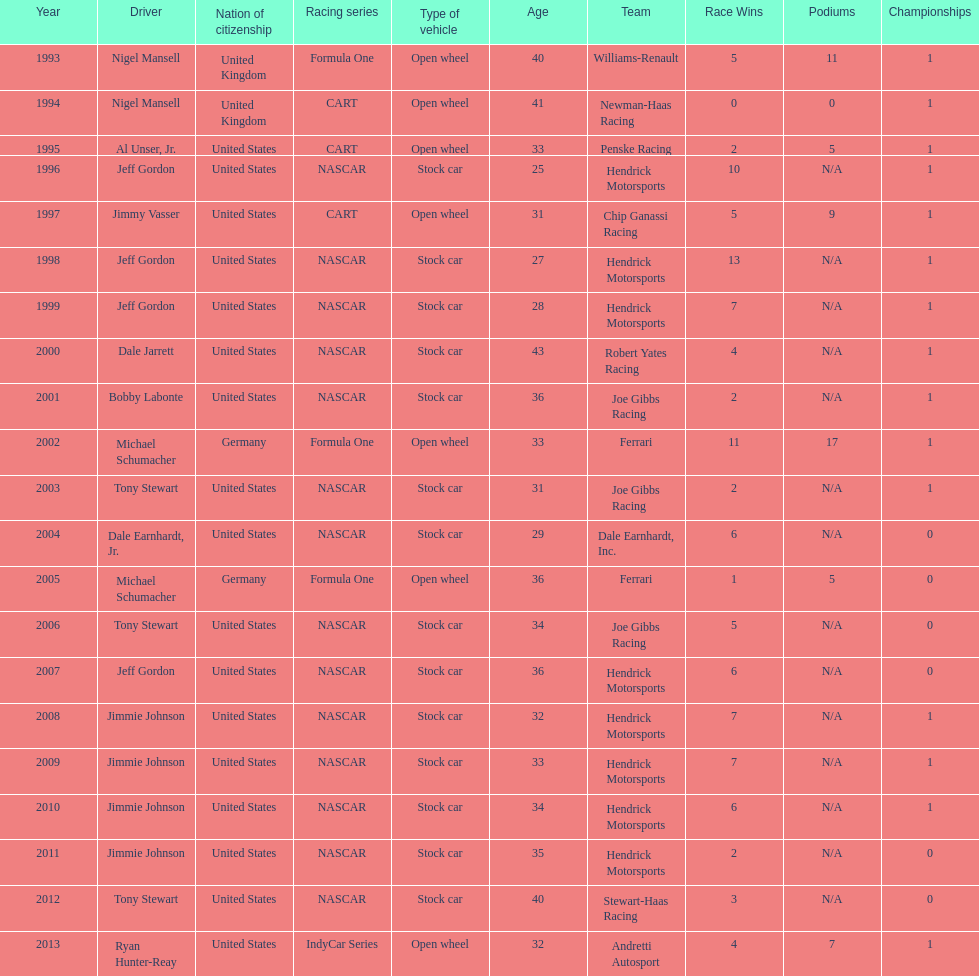Out of these drivers: nigel mansell, al unser, jr., michael schumacher, and jeff gordon, all but one has more than one espy award. who only has one espy award? Al Unser, Jr. Could you parse the entire table? {'header': ['Year', 'Driver', 'Nation of citizenship', 'Racing series', 'Type of vehicle', 'Age', 'Team', 'Race Wins', 'Podiums', 'Championships'], 'rows': [['1993', 'Nigel Mansell', 'United Kingdom', 'Formula One', 'Open wheel', '40', 'Williams-Renault', '5', '11', '1'], ['1994', 'Nigel Mansell', 'United Kingdom', 'CART', 'Open wheel', '41', 'Newman-Haas Racing', '0', '0', '1'], ['1995', 'Al Unser, Jr.', 'United States', 'CART', 'Open wheel', '33', 'Penske Racing', '2', '5', '1'], ['1996', 'Jeff Gordon', 'United States', 'NASCAR', 'Stock car', '25', 'Hendrick Motorsports', '10', 'N/A', '1'], ['1997', 'Jimmy Vasser', 'United States', 'CART', 'Open wheel', '31', 'Chip Ganassi Racing', '5', '9', '1'], ['1998', 'Jeff Gordon', 'United States', 'NASCAR', 'Stock car', '27', 'Hendrick Motorsports', '13', 'N/A', '1'], ['1999', 'Jeff Gordon', 'United States', 'NASCAR', 'Stock car', '28', 'Hendrick Motorsports', '7', 'N/A', '1'], ['2000', 'Dale Jarrett', 'United States', 'NASCAR', 'Stock car', '43', 'Robert Yates Racing', '4', 'N/A', '1'], ['2001', 'Bobby Labonte', 'United States', 'NASCAR', 'Stock car', '36', 'Joe Gibbs Racing', '2', 'N/A', '1'], ['2002', 'Michael Schumacher', 'Germany', 'Formula One', 'Open wheel', '33', 'Ferrari', '11', '17', '1'], ['2003', 'Tony Stewart', 'United States', 'NASCAR', 'Stock car', '31', 'Joe Gibbs Racing', '2', 'N/A', '1'], ['2004', 'Dale Earnhardt, Jr.', 'United States', 'NASCAR', 'Stock car', '29', 'Dale Earnhardt, Inc.', '6', 'N/A', '0'], ['2005', 'Michael Schumacher', 'Germany', 'Formula One', 'Open wheel', '36', 'Ferrari', '1', '5', '0'], ['2006', 'Tony Stewart', 'United States', 'NASCAR', 'Stock car', '34', 'Joe Gibbs Racing', '5', 'N/A', '0'], ['2007', 'Jeff Gordon', 'United States', 'NASCAR', 'Stock car', '36', 'Hendrick Motorsports', '6', 'N/A', '0'], ['2008', 'Jimmie Johnson', 'United States', 'NASCAR', 'Stock car', '32', 'Hendrick Motorsports', '7', 'N/A', '1'], ['2009', 'Jimmie Johnson', 'United States', 'NASCAR', 'Stock car', '33', 'Hendrick Motorsports', '7', 'N/A', '1'], ['2010', 'Jimmie Johnson', 'United States', 'NASCAR', 'Stock car', '34', 'Hendrick Motorsports', '6', 'N/A', '1'], ['2011', 'Jimmie Johnson', 'United States', 'NASCAR', 'Stock car', '35', 'Hendrick Motorsports', '2', 'N/A', '0'], ['2012', 'Tony Stewart', 'United States', 'NASCAR', 'Stock car', '40', 'Stewart-Haas Racing', '3', 'N/A', '0'], ['2013', 'Ryan Hunter-Reay', 'United States', 'IndyCar Series', 'Open wheel', '32', 'Andretti Autosport', '4', '7', '1']]} 